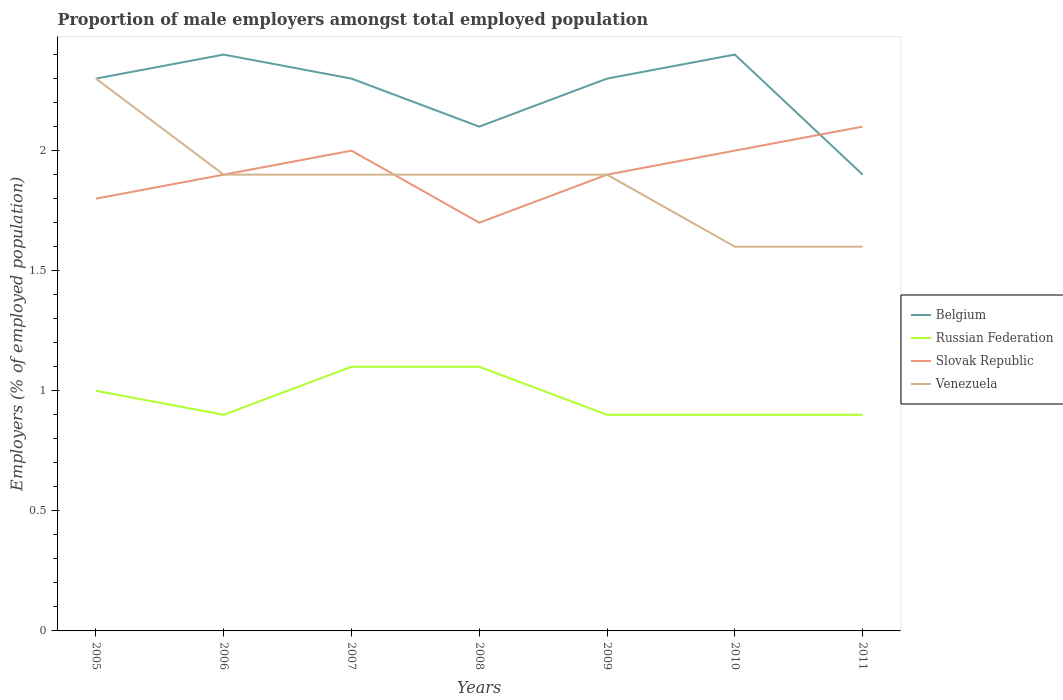How many different coloured lines are there?
Give a very brief answer. 4. Does the line corresponding to Slovak Republic intersect with the line corresponding to Russian Federation?
Offer a very short reply. No. Across all years, what is the maximum proportion of male employers in Belgium?
Your response must be concise. 1.9. What is the total proportion of male employers in Venezuela in the graph?
Your answer should be compact. 0.3. What is the difference between the highest and the second highest proportion of male employers in Russian Federation?
Provide a succinct answer. 0.2. How many years are there in the graph?
Provide a succinct answer. 7. Are the values on the major ticks of Y-axis written in scientific E-notation?
Make the answer very short. No. Does the graph contain any zero values?
Your answer should be very brief. No. Where does the legend appear in the graph?
Give a very brief answer. Center right. What is the title of the graph?
Your answer should be compact. Proportion of male employers amongst total employed population. What is the label or title of the Y-axis?
Offer a terse response. Employers (% of employed population). What is the Employers (% of employed population) of Belgium in 2005?
Your answer should be compact. 2.3. What is the Employers (% of employed population) of Russian Federation in 2005?
Your answer should be very brief. 1. What is the Employers (% of employed population) in Slovak Republic in 2005?
Ensure brevity in your answer.  1.8. What is the Employers (% of employed population) of Venezuela in 2005?
Keep it short and to the point. 2.3. What is the Employers (% of employed population) of Belgium in 2006?
Ensure brevity in your answer.  2.4. What is the Employers (% of employed population) of Russian Federation in 2006?
Offer a terse response. 0.9. What is the Employers (% of employed population) of Slovak Republic in 2006?
Offer a very short reply. 1.9. What is the Employers (% of employed population) of Venezuela in 2006?
Provide a succinct answer. 1.9. What is the Employers (% of employed population) of Belgium in 2007?
Provide a short and direct response. 2.3. What is the Employers (% of employed population) in Russian Federation in 2007?
Ensure brevity in your answer.  1.1. What is the Employers (% of employed population) in Slovak Republic in 2007?
Give a very brief answer. 2. What is the Employers (% of employed population) in Venezuela in 2007?
Keep it short and to the point. 1.9. What is the Employers (% of employed population) in Belgium in 2008?
Your answer should be very brief. 2.1. What is the Employers (% of employed population) of Russian Federation in 2008?
Offer a terse response. 1.1. What is the Employers (% of employed population) in Slovak Republic in 2008?
Offer a very short reply. 1.7. What is the Employers (% of employed population) in Venezuela in 2008?
Offer a very short reply. 1.9. What is the Employers (% of employed population) of Belgium in 2009?
Your answer should be very brief. 2.3. What is the Employers (% of employed population) in Russian Federation in 2009?
Provide a succinct answer. 0.9. What is the Employers (% of employed population) of Slovak Republic in 2009?
Keep it short and to the point. 1.9. What is the Employers (% of employed population) in Venezuela in 2009?
Provide a succinct answer. 1.9. What is the Employers (% of employed population) of Belgium in 2010?
Make the answer very short. 2.4. What is the Employers (% of employed population) in Russian Federation in 2010?
Ensure brevity in your answer.  0.9. What is the Employers (% of employed population) in Slovak Republic in 2010?
Make the answer very short. 2. What is the Employers (% of employed population) of Venezuela in 2010?
Provide a short and direct response. 1.6. What is the Employers (% of employed population) in Belgium in 2011?
Your response must be concise. 1.9. What is the Employers (% of employed population) of Russian Federation in 2011?
Your answer should be compact. 0.9. What is the Employers (% of employed population) in Slovak Republic in 2011?
Give a very brief answer. 2.1. What is the Employers (% of employed population) of Venezuela in 2011?
Ensure brevity in your answer.  1.6. Across all years, what is the maximum Employers (% of employed population) in Belgium?
Make the answer very short. 2.4. Across all years, what is the maximum Employers (% of employed population) in Russian Federation?
Make the answer very short. 1.1. Across all years, what is the maximum Employers (% of employed population) of Slovak Republic?
Provide a short and direct response. 2.1. Across all years, what is the maximum Employers (% of employed population) of Venezuela?
Make the answer very short. 2.3. Across all years, what is the minimum Employers (% of employed population) in Belgium?
Your answer should be compact. 1.9. Across all years, what is the minimum Employers (% of employed population) of Russian Federation?
Give a very brief answer. 0.9. Across all years, what is the minimum Employers (% of employed population) in Slovak Republic?
Your answer should be compact. 1.7. Across all years, what is the minimum Employers (% of employed population) in Venezuela?
Make the answer very short. 1.6. What is the total Employers (% of employed population) of Belgium in the graph?
Make the answer very short. 15.7. What is the total Employers (% of employed population) of Russian Federation in the graph?
Ensure brevity in your answer.  6.8. What is the total Employers (% of employed population) of Venezuela in the graph?
Offer a very short reply. 13.1. What is the difference between the Employers (% of employed population) in Russian Federation in 2005 and that in 2006?
Offer a very short reply. 0.1. What is the difference between the Employers (% of employed population) of Venezuela in 2005 and that in 2006?
Your answer should be very brief. 0.4. What is the difference between the Employers (% of employed population) of Belgium in 2005 and that in 2007?
Provide a succinct answer. 0. What is the difference between the Employers (% of employed population) of Russian Federation in 2005 and that in 2007?
Offer a very short reply. -0.1. What is the difference between the Employers (% of employed population) in Venezuela in 2005 and that in 2007?
Your response must be concise. 0.4. What is the difference between the Employers (% of employed population) in Belgium in 2005 and that in 2008?
Your answer should be compact. 0.2. What is the difference between the Employers (% of employed population) in Venezuela in 2005 and that in 2008?
Make the answer very short. 0.4. What is the difference between the Employers (% of employed population) in Belgium in 2005 and that in 2010?
Provide a succinct answer. -0.1. What is the difference between the Employers (% of employed population) in Russian Federation in 2005 and that in 2010?
Offer a terse response. 0.1. What is the difference between the Employers (% of employed population) in Belgium in 2005 and that in 2011?
Provide a short and direct response. 0.4. What is the difference between the Employers (% of employed population) in Slovak Republic in 2005 and that in 2011?
Provide a succinct answer. -0.3. What is the difference between the Employers (% of employed population) of Russian Federation in 2006 and that in 2007?
Make the answer very short. -0.2. What is the difference between the Employers (% of employed population) of Russian Federation in 2006 and that in 2008?
Keep it short and to the point. -0.2. What is the difference between the Employers (% of employed population) of Russian Federation in 2006 and that in 2009?
Offer a very short reply. 0. What is the difference between the Employers (% of employed population) in Slovak Republic in 2006 and that in 2009?
Offer a very short reply. 0. What is the difference between the Employers (% of employed population) in Belgium in 2006 and that in 2010?
Your response must be concise. 0. What is the difference between the Employers (% of employed population) of Belgium in 2006 and that in 2011?
Offer a terse response. 0.5. What is the difference between the Employers (% of employed population) in Slovak Republic in 2006 and that in 2011?
Keep it short and to the point. -0.2. What is the difference between the Employers (% of employed population) of Russian Federation in 2007 and that in 2008?
Offer a terse response. 0. What is the difference between the Employers (% of employed population) of Slovak Republic in 2007 and that in 2008?
Your response must be concise. 0.3. What is the difference between the Employers (% of employed population) in Belgium in 2007 and that in 2009?
Offer a terse response. 0. What is the difference between the Employers (% of employed population) of Slovak Republic in 2007 and that in 2010?
Provide a short and direct response. 0. What is the difference between the Employers (% of employed population) of Belgium in 2007 and that in 2011?
Offer a very short reply. 0.4. What is the difference between the Employers (% of employed population) of Russian Federation in 2007 and that in 2011?
Make the answer very short. 0.2. What is the difference between the Employers (% of employed population) in Venezuela in 2007 and that in 2011?
Offer a very short reply. 0.3. What is the difference between the Employers (% of employed population) in Slovak Republic in 2008 and that in 2009?
Offer a very short reply. -0.2. What is the difference between the Employers (% of employed population) in Slovak Republic in 2008 and that in 2011?
Keep it short and to the point. -0.4. What is the difference between the Employers (% of employed population) of Russian Federation in 2009 and that in 2010?
Make the answer very short. 0. What is the difference between the Employers (% of employed population) of Venezuela in 2009 and that in 2010?
Ensure brevity in your answer.  0.3. What is the difference between the Employers (% of employed population) of Venezuela in 2009 and that in 2011?
Keep it short and to the point. 0.3. What is the difference between the Employers (% of employed population) of Russian Federation in 2010 and that in 2011?
Offer a terse response. 0. What is the difference between the Employers (% of employed population) of Slovak Republic in 2010 and that in 2011?
Keep it short and to the point. -0.1. What is the difference between the Employers (% of employed population) in Venezuela in 2010 and that in 2011?
Give a very brief answer. 0. What is the difference between the Employers (% of employed population) of Belgium in 2005 and the Employers (% of employed population) of Russian Federation in 2006?
Keep it short and to the point. 1.4. What is the difference between the Employers (% of employed population) in Belgium in 2005 and the Employers (% of employed population) in Venezuela in 2006?
Make the answer very short. 0.4. What is the difference between the Employers (% of employed population) in Russian Federation in 2005 and the Employers (% of employed population) in Venezuela in 2006?
Offer a terse response. -0.9. What is the difference between the Employers (% of employed population) in Slovak Republic in 2005 and the Employers (% of employed population) in Venezuela in 2006?
Give a very brief answer. -0.1. What is the difference between the Employers (% of employed population) in Belgium in 2005 and the Employers (% of employed population) in Venezuela in 2007?
Your answer should be compact. 0.4. What is the difference between the Employers (% of employed population) of Russian Federation in 2005 and the Employers (% of employed population) of Slovak Republic in 2007?
Your answer should be compact. -1. What is the difference between the Employers (% of employed population) in Russian Federation in 2005 and the Employers (% of employed population) in Venezuela in 2007?
Keep it short and to the point. -0.9. What is the difference between the Employers (% of employed population) of Belgium in 2005 and the Employers (% of employed population) of Venezuela in 2008?
Your answer should be very brief. 0.4. What is the difference between the Employers (% of employed population) of Slovak Republic in 2005 and the Employers (% of employed population) of Venezuela in 2008?
Provide a short and direct response. -0.1. What is the difference between the Employers (% of employed population) of Belgium in 2005 and the Employers (% of employed population) of Russian Federation in 2009?
Your answer should be very brief. 1.4. What is the difference between the Employers (% of employed population) in Belgium in 2005 and the Employers (% of employed population) in Slovak Republic in 2009?
Make the answer very short. 0.4. What is the difference between the Employers (% of employed population) of Belgium in 2005 and the Employers (% of employed population) of Venezuela in 2009?
Give a very brief answer. 0.4. What is the difference between the Employers (% of employed population) of Russian Federation in 2005 and the Employers (% of employed population) of Slovak Republic in 2009?
Provide a short and direct response. -0.9. What is the difference between the Employers (% of employed population) in Slovak Republic in 2005 and the Employers (% of employed population) in Venezuela in 2009?
Your response must be concise. -0.1. What is the difference between the Employers (% of employed population) in Russian Federation in 2005 and the Employers (% of employed population) in Slovak Republic in 2010?
Provide a short and direct response. -1. What is the difference between the Employers (% of employed population) of Russian Federation in 2005 and the Employers (% of employed population) of Venezuela in 2010?
Your answer should be compact. -0.6. What is the difference between the Employers (% of employed population) of Slovak Republic in 2005 and the Employers (% of employed population) of Venezuela in 2010?
Offer a very short reply. 0.2. What is the difference between the Employers (% of employed population) of Belgium in 2005 and the Employers (% of employed population) of Slovak Republic in 2011?
Give a very brief answer. 0.2. What is the difference between the Employers (% of employed population) in Belgium in 2005 and the Employers (% of employed population) in Venezuela in 2011?
Provide a short and direct response. 0.7. What is the difference between the Employers (% of employed population) of Russian Federation in 2005 and the Employers (% of employed population) of Slovak Republic in 2011?
Give a very brief answer. -1.1. What is the difference between the Employers (% of employed population) in Russian Federation in 2005 and the Employers (% of employed population) in Venezuela in 2011?
Make the answer very short. -0.6. What is the difference between the Employers (% of employed population) in Slovak Republic in 2005 and the Employers (% of employed population) in Venezuela in 2011?
Offer a very short reply. 0.2. What is the difference between the Employers (% of employed population) in Belgium in 2006 and the Employers (% of employed population) in Russian Federation in 2007?
Offer a terse response. 1.3. What is the difference between the Employers (% of employed population) of Belgium in 2006 and the Employers (% of employed population) of Slovak Republic in 2007?
Ensure brevity in your answer.  0.4. What is the difference between the Employers (% of employed population) of Slovak Republic in 2006 and the Employers (% of employed population) of Venezuela in 2007?
Give a very brief answer. 0. What is the difference between the Employers (% of employed population) of Belgium in 2006 and the Employers (% of employed population) of Russian Federation in 2008?
Offer a terse response. 1.3. What is the difference between the Employers (% of employed population) of Belgium in 2006 and the Employers (% of employed population) of Slovak Republic in 2008?
Your answer should be compact. 0.7. What is the difference between the Employers (% of employed population) in Belgium in 2006 and the Employers (% of employed population) in Venezuela in 2008?
Provide a short and direct response. 0.5. What is the difference between the Employers (% of employed population) in Russian Federation in 2006 and the Employers (% of employed population) in Slovak Republic in 2008?
Offer a very short reply. -0.8. What is the difference between the Employers (% of employed population) in Slovak Republic in 2006 and the Employers (% of employed population) in Venezuela in 2008?
Provide a short and direct response. 0. What is the difference between the Employers (% of employed population) in Belgium in 2006 and the Employers (% of employed population) in Slovak Republic in 2009?
Provide a succinct answer. 0.5. What is the difference between the Employers (% of employed population) in Belgium in 2006 and the Employers (% of employed population) in Venezuela in 2009?
Provide a succinct answer. 0.5. What is the difference between the Employers (% of employed population) of Russian Federation in 2006 and the Employers (% of employed population) of Venezuela in 2009?
Provide a succinct answer. -1. What is the difference between the Employers (% of employed population) of Slovak Republic in 2006 and the Employers (% of employed population) of Venezuela in 2009?
Provide a short and direct response. 0. What is the difference between the Employers (% of employed population) of Belgium in 2006 and the Employers (% of employed population) of Slovak Republic in 2010?
Provide a succinct answer. 0.4. What is the difference between the Employers (% of employed population) of Russian Federation in 2006 and the Employers (% of employed population) of Venezuela in 2010?
Ensure brevity in your answer.  -0.7. What is the difference between the Employers (% of employed population) in Slovak Republic in 2006 and the Employers (% of employed population) in Venezuela in 2010?
Give a very brief answer. 0.3. What is the difference between the Employers (% of employed population) of Belgium in 2006 and the Employers (% of employed population) of Slovak Republic in 2011?
Ensure brevity in your answer.  0.3. What is the difference between the Employers (% of employed population) in Belgium in 2007 and the Employers (% of employed population) in Russian Federation in 2008?
Offer a very short reply. 1.2. What is the difference between the Employers (% of employed population) of Russian Federation in 2007 and the Employers (% of employed population) of Slovak Republic in 2008?
Provide a short and direct response. -0.6. What is the difference between the Employers (% of employed population) in Russian Federation in 2007 and the Employers (% of employed population) in Venezuela in 2008?
Offer a terse response. -0.8. What is the difference between the Employers (% of employed population) in Slovak Republic in 2007 and the Employers (% of employed population) in Venezuela in 2008?
Provide a succinct answer. 0.1. What is the difference between the Employers (% of employed population) in Belgium in 2007 and the Employers (% of employed population) in Russian Federation in 2009?
Your answer should be compact. 1.4. What is the difference between the Employers (% of employed population) of Russian Federation in 2007 and the Employers (% of employed population) of Slovak Republic in 2009?
Your answer should be very brief. -0.8. What is the difference between the Employers (% of employed population) of Russian Federation in 2007 and the Employers (% of employed population) of Venezuela in 2009?
Your answer should be compact. -0.8. What is the difference between the Employers (% of employed population) in Slovak Republic in 2007 and the Employers (% of employed population) in Venezuela in 2009?
Offer a very short reply. 0.1. What is the difference between the Employers (% of employed population) of Russian Federation in 2007 and the Employers (% of employed population) of Venezuela in 2010?
Keep it short and to the point. -0.5. What is the difference between the Employers (% of employed population) of Russian Federation in 2007 and the Employers (% of employed population) of Venezuela in 2011?
Provide a short and direct response. -0.5. What is the difference between the Employers (% of employed population) in Belgium in 2008 and the Employers (% of employed population) in Russian Federation in 2009?
Your answer should be very brief. 1.2. What is the difference between the Employers (% of employed population) of Slovak Republic in 2008 and the Employers (% of employed population) of Venezuela in 2009?
Offer a very short reply. -0.2. What is the difference between the Employers (% of employed population) in Russian Federation in 2008 and the Employers (% of employed population) in Venezuela in 2011?
Ensure brevity in your answer.  -0.5. What is the difference between the Employers (% of employed population) in Belgium in 2009 and the Employers (% of employed population) in Russian Federation in 2010?
Your response must be concise. 1.4. What is the difference between the Employers (% of employed population) in Belgium in 2009 and the Employers (% of employed population) in Venezuela in 2010?
Give a very brief answer. 0.7. What is the difference between the Employers (% of employed population) in Russian Federation in 2009 and the Employers (% of employed population) in Venezuela in 2010?
Ensure brevity in your answer.  -0.7. What is the difference between the Employers (% of employed population) of Belgium in 2009 and the Employers (% of employed population) of Slovak Republic in 2011?
Your answer should be compact. 0.2. What is the difference between the Employers (% of employed population) in Belgium in 2009 and the Employers (% of employed population) in Venezuela in 2011?
Your response must be concise. 0.7. What is the difference between the Employers (% of employed population) in Russian Federation in 2009 and the Employers (% of employed population) in Slovak Republic in 2011?
Your answer should be compact. -1.2. What is the difference between the Employers (% of employed population) of Russian Federation in 2009 and the Employers (% of employed population) of Venezuela in 2011?
Your response must be concise. -0.7. What is the difference between the Employers (% of employed population) in Belgium in 2010 and the Employers (% of employed population) in Slovak Republic in 2011?
Keep it short and to the point. 0.3. What is the difference between the Employers (% of employed population) in Russian Federation in 2010 and the Employers (% of employed population) in Venezuela in 2011?
Ensure brevity in your answer.  -0.7. What is the difference between the Employers (% of employed population) in Slovak Republic in 2010 and the Employers (% of employed population) in Venezuela in 2011?
Your answer should be very brief. 0.4. What is the average Employers (% of employed population) in Belgium per year?
Provide a succinct answer. 2.24. What is the average Employers (% of employed population) of Russian Federation per year?
Make the answer very short. 0.97. What is the average Employers (% of employed population) in Slovak Republic per year?
Keep it short and to the point. 1.91. What is the average Employers (% of employed population) of Venezuela per year?
Offer a very short reply. 1.87. In the year 2005, what is the difference between the Employers (% of employed population) in Belgium and Employers (% of employed population) in Russian Federation?
Keep it short and to the point. 1.3. In the year 2005, what is the difference between the Employers (% of employed population) of Russian Federation and Employers (% of employed population) of Slovak Republic?
Offer a terse response. -0.8. In the year 2005, what is the difference between the Employers (% of employed population) in Russian Federation and Employers (% of employed population) in Venezuela?
Your answer should be very brief. -1.3. In the year 2005, what is the difference between the Employers (% of employed population) in Slovak Republic and Employers (% of employed population) in Venezuela?
Your answer should be compact. -0.5. In the year 2006, what is the difference between the Employers (% of employed population) of Belgium and Employers (% of employed population) of Russian Federation?
Keep it short and to the point. 1.5. In the year 2006, what is the difference between the Employers (% of employed population) of Belgium and Employers (% of employed population) of Venezuela?
Make the answer very short. 0.5. In the year 2007, what is the difference between the Employers (% of employed population) in Belgium and Employers (% of employed population) in Slovak Republic?
Your response must be concise. 0.3. In the year 2007, what is the difference between the Employers (% of employed population) in Russian Federation and Employers (% of employed population) in Slovak Republic?
Your response must be concise. -0.9. In the year 2008, what is the difference between the Employers (% of employed population) of Belgium and Employers (% of employed population) of Venezuela?
Make the answer very short. 0.2. In the year 2008, what is the difference between the Employers (% of employed population) in Russian Federation and Employers (% of employed population) in Slovak Republic?
Keep it short and to the point. -0.6. In the year 2008, what is the difference between the Employers (% of employed population) in Slovak Republic and Employers (% of employed population) in Venezuela?
Your answer should be very brief. -0.2. In the year 2009, what is the difference between the Employers (% of employed population) in Belgium and Employers (% of employed population) in Russian Federation?
Ensure brevity in your answer.  1.4. In the year 2009, what is the difference between the Employers (% of employed population) in Russian Federation and Employers (% of employed population) in Venezuela?
Provide a short and direct response. -1. In the year 2010, what is the difference between the Employers (% of employed population) in Belgium and Employers (% of employed population) in Slovak Republic?
Ensure brevity in your answer.  0.4. In the year 2010, what is the difference between the Employers (% of employed population) of Belgium and Employers (% of employed population) of Venezuela?
Give a very brief answer. 0.8. In the year 2010, what is the difference between the Employers (% of employed population) in Russian Federation and Employers (% of employed population) in Slovak Republic?
Your answer should be compact. -1.1. In the year 2011, what is the difference between the Employers (% of employed population) of Belgium and Employers (% of employed population) of Russian Federation?
Give a very brief answer. 1. In the year 2011, what is the difference between the Employers (% of employed population) in Belgium and Employers (% of employed population) in Slovak Republic?
Give a very brief answer. -0.2. In the year 2011, what is the difference between the Employers (% of employed population) in Belgium and Employers (% of employed population) in Venezuela?
Give a very brief answer. 0.3. What is the ratio of the Employers (% of employed population) in Venezuela in 2005 to that in 2006?
Keep it short and to the point. 1.21. What is the ratio of the Employers (% of employed population) in Slovak Republic in 2005 to that in 2007?
Make the answer very short. 0.9. What is the ratio of the Employers (% of employed population) in Venezuela in 2005 to that in 2007?
Make the answer very short. 1.21. What is the ratio of the Employers (% of employed population) of Belgium in 2005 to that in 2008?
Ensure brevity in your answer.  1.1. What is the ratio of the Employers (% of employed population) of Russian Federation in 2005 to that in 2008?
Your answer should be very brief. 0.91. What is the ratio of the Employers (% of employed population) in Slovak Republic in 2005 to that in 2008?
Offer a terse response. 1.06. What is the ratio of the Employers (% of employed population) in Venezuela in 2005 to that in 2008?
Provide a succinct answer. 1.21. What is the ratio of the Employers (% of employed population) of Venezuela in 2005 to that in 2009?
Give a very brief answer. 1.21. What is the ratio of the Employers (% of employed population) in Belgium in 2005 to that in 2010?
Your response must be concise. 0.96. What is the ratio of the Employers (% of employed population) of Russian Federation in 2005 to that in 2010?
Your response must be concise. 1.11. What is the ratio of the Employers (% of employed population) of Slovak Republic in 2005 to that in 2010?
Provide a succinct answer. 0.9. What is the ratio of the Employers (% of employed population) in Venezuela in 2005 to that in 2010?
Give a very brief answer. 1.44. What is the ratio of the Employers (% of employed population) in Belgium in 2005 to that in 2011?
Your answer should be compact. 1.21. What is the ratio of the Employers (% of employed population) in Russian Federation in 2005 to that in 2011?
Your answer should be very brief. 1.11. What is the ratio of the Employers (% of employed population) of Slovak Republic in 2005 to that in 2011?
Provide a succinct answer. 0.86. What is the ratio of the Employers (% of employed population) of Venezuela in 2005 to that in 2011?
Provide a short and direct response. 1.44. What is the ratio of the Employers (% of employed population) in Belgium in 2006 to that in 2007?
Ensure brevity in your answer.  1.04. What is the ratio of the Employers (% of employed population) of Russian Federation in 2006 to that in 2007?
Your answer should be compact. 0.82. What is the ratio of the Employers (% of employed population) of Belgium in 2006 to that in 2008?
Offer a very short reply. 1.14. What is the ratio of the Employers (% of employed population) of Russian Federation in 2006 to that in 2008?
Keep it short and to the point. 0.82. What is the ratio of the Employers (% of employed population) of Slovak Republic in 2006 to that in 2008?
Keep it short and to the point. 1.12. What is the ratio of the Employers (% of employed population) in Venezuela in 2006 to that in 2008?
Provide a short and direct response. 1. What is the ratio of the Employers (% of employed population) in Belgium in 2006 to that in 2009?
Provide a succinct answer. 1.04. What is the ratio of the Employers (% of employed population) in Belgium in 2006 to that in 2010?
Offer a terse response. 1. What is the ratio of the Employers (% of employed population) of Slovak Republic in 2006 to that in 2010?
Your answer should be compact. 0.95. What is the ratio of the Employers (% of employed population) in Venezuela in 2006 to that in 2010?
Keep it short and to the point. 1.19. What is the ratio of the Employers (% of employed population) of Belgium in 2006 to that in 2011?
Offer a very short reply. 1.26. What is the ratio of the Employers (% of employed population) of Slovak Republic in 2006 to that in 2011?
Your answer should be compact. 0.9. What is the ratio of the Employers (% of employed population) in Venezuela in 2006 to that in 2011?
Provide a succinct answer. 1.19. What is the ratio of the Employers (% of employed population) in Belgium in 2007 to that in 2008?
Provide a succinct answer. 1.1. What is the ratio of the Employers (% of employed population) in Russian Federation in 2007 to that in 2008?
Make the answer very short. 1. What is the ratio of the Employers (% of employed population) in Slovak Republic in 2007 to that in 2008?
Your response must be concise. 1.18. What is the ratio of the Employers (% of employed population) in Russian Federation in 2007 to that in 2009?
Make the answer very short. 1.22. What is the ratio of the Employers (% of employed population) of Slovak Republic in 2007 to that in 2009?
Offer a terse response. 1.05. What is the ratio of the Employers (% of employed population) of Belgium in 2007 to that in 2010?
Your response must be concise. 0.96. What is the ratio of the Employers (% of employed population) of Russian Federation in 2007 to that in 2010?
Offer a very short reply. 1.22. What is the ratio of the Employers (% of employed population) of Venezuela in 2007 to that in 2010?
Provide a succinct answer. 1.19. What is the ratio of the Employers (% of employed population) of Belgium in 2007 to that in 2011?
Provide a succinct answer. 1.21. What is the ratio of the Employers (% of employed population) in Russian Federation in 2007 to that in 2011?
Keep it short and to the point. 1.22. What is the ratio of the Employers (% of employed population) of Slovak Republic in 2007 to that in 2011?
Give a very brief answer. 0.95. What is the ratio of the Employers (% of employed population) in Venezuela in 2007 to that in 2011?
Offer a very short reply. 1.19. What is the ratio of the Employers (% of employed population) of Belgium in 2008 to that in 2009?
Keep it short and to the point. 0.91. What is the ratio of the Employers (% of employed population) in Russian Federation in 2008 to that in 2009?
Ensure brevity in your answer.  1.22. What is the ratio of the Employers (% of employed population) of Slovak Republic in 2008 to that in 2009?
Provide a short and direct response. 0.89. What is the ratio of the Employers (% of employed population) in Venezuela in 2008 to that in 2009?
Provide a succinct answer. 1. What is the ratio of the Employers (% of employed population) of Russian Federation in 2008 to that in 2010?
Offer a very short reply. 1.22. What is the ratio of the Employers (% of employed population) of Venezuela in 2008 to that in 2010?
Make the answer very short. 1.19. What is the ratio of the Employers (% of employed population) in Belgium in 2008 to that in 2011?
Your answer should be very brief. 1.11. What is the ratio of the Employers (% of employed population) of Russian Federation in 2008 to that in 2011?
Your answer should be compact. 1.22. What is the ratio of the Employers (% of employed population) of Slovak Republic in 2008 to that in 2011?
Offer a very short reply. 0.81. What is the ratio of the Employers (% of employed population) in Venezuela in 2008 to that in 2011?
Offer a terse response. 1.19. What is the ratio of the Employers (% of employed population) in Slovak Republic in 2009 to that in 2010?
Offer a very short reply. 0.95. What is the ratio of the Employers (% of employed population) of Venezuela in 2009 to that in 2010?
Keep it short and to the point. 1.19. What is the ratio of the Employers (% of employed population) in Belgium in 2009 to that in 2011?
Provide a succinct answer. 1.21. What is the ratio of the Employers (% of employed population) in Slovak Republic in 2009 to that in 2011?
Your response must be concise. 0.9. What is the ratio of the Employers (% of employed population) of Venezuela in 2009 to that in 2011?
Your response must be concise. 1.19. What is the ratio of the Employers (% of employed population) in Belgium in 2010 to that in 2011?
Make the answer very short. 1.26. What is the ratio of the Employers (% of employed population) in Russian Federation in 2010 to that in 2011?
Make the answer very short. 1. What is the difference between the highest and the second highest Employers (% of employed population) of Belgium?
Ensure brevity in your answer.  0. What is the difference between the highest and the second highest Employers (% of employed population) of Russian Federation?
Offer a very short reply. 0. What is the difference between the highest and the second highest Employers (% of employed population) in Slovak Republic?
Provide a short and direct response. 0.1. What is the difference between the highest and the second highest Employers (% of employed population) of Venezuela?
Your answer should be compact. 0.4. 